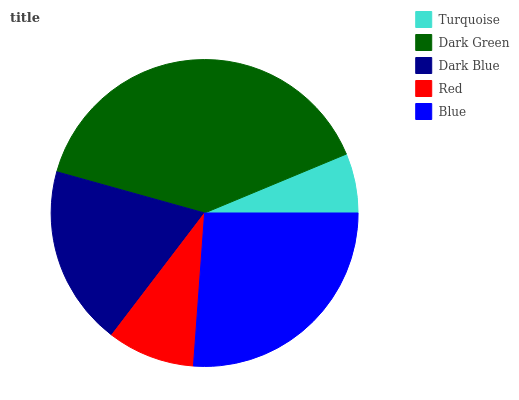Is Turquoise the minimum?
Answer yes or no. Yes. Is Dark Green the maximum?
Answer yes or no. Yes. Is Dark Blue the minimum?
Answer yes or no. No. Is Dark Blue the maximum?
Answer yes or no. No. Is Dark Green greater than Dark Blue?
Answer yes or no. Yes. Is Dark Blue less than Dark Green?
Answer yes or no. Yes. Is Dark Blue greater than Dark Green?
Answer yes or no. No. Is Dark Green less than Dark Blue?
Answer yes or no. No. Is Dark Blue the high median?
Answer yes or no. Yes. Is Dark Blue the low median?
Answer yes or no. Yes. Is Dark Green the high median?
Answer yes or no. No. Is Turquoise the low median?
Answer yes or no. No. 